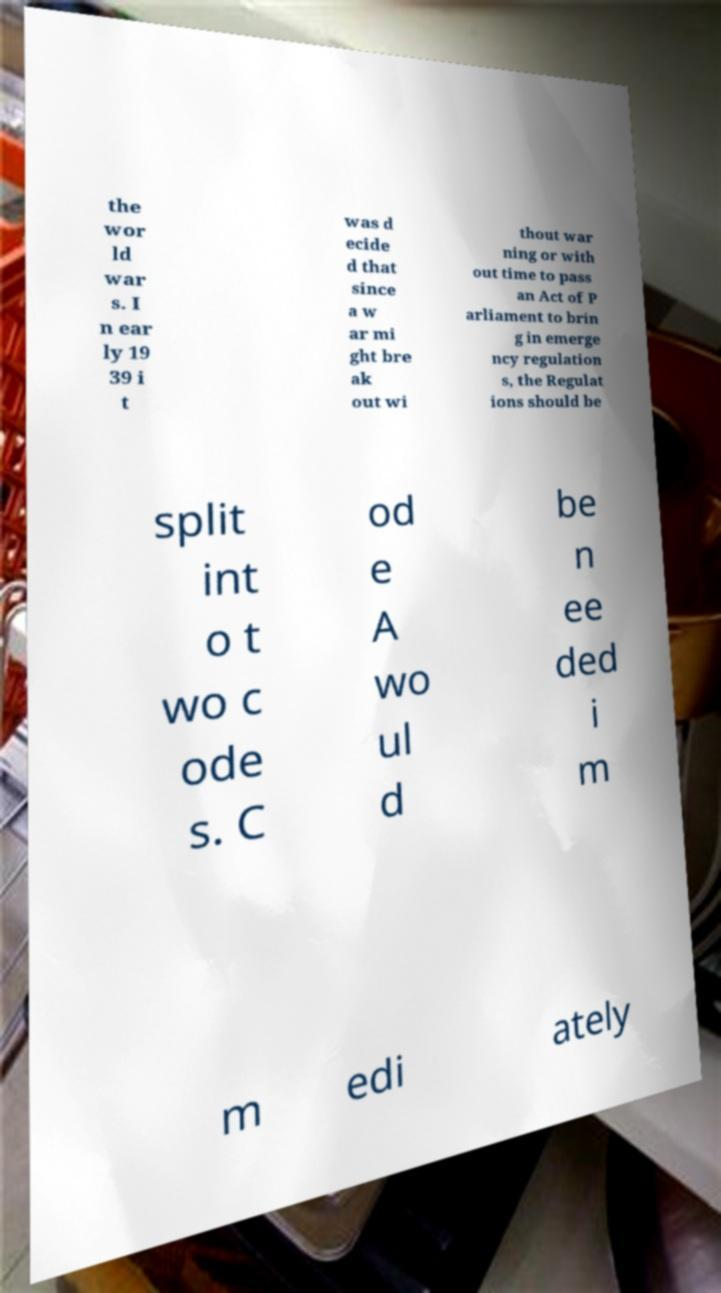Can you read and provide the text displayed in the image?This photo seems to have some interesting text. Can you extract and type it out for me? the wor ld war s. I n ear ly 19 39 i t was d ecide d that since a w ar mi ght bre ak out wi thout war ning or with out time to pass an Act of P arliament to brin g in emerge ncy regulation s, the Regulat ions should be split int o t wo c ode s. C od e A wo ul d be n ee ded i m m edi ately 